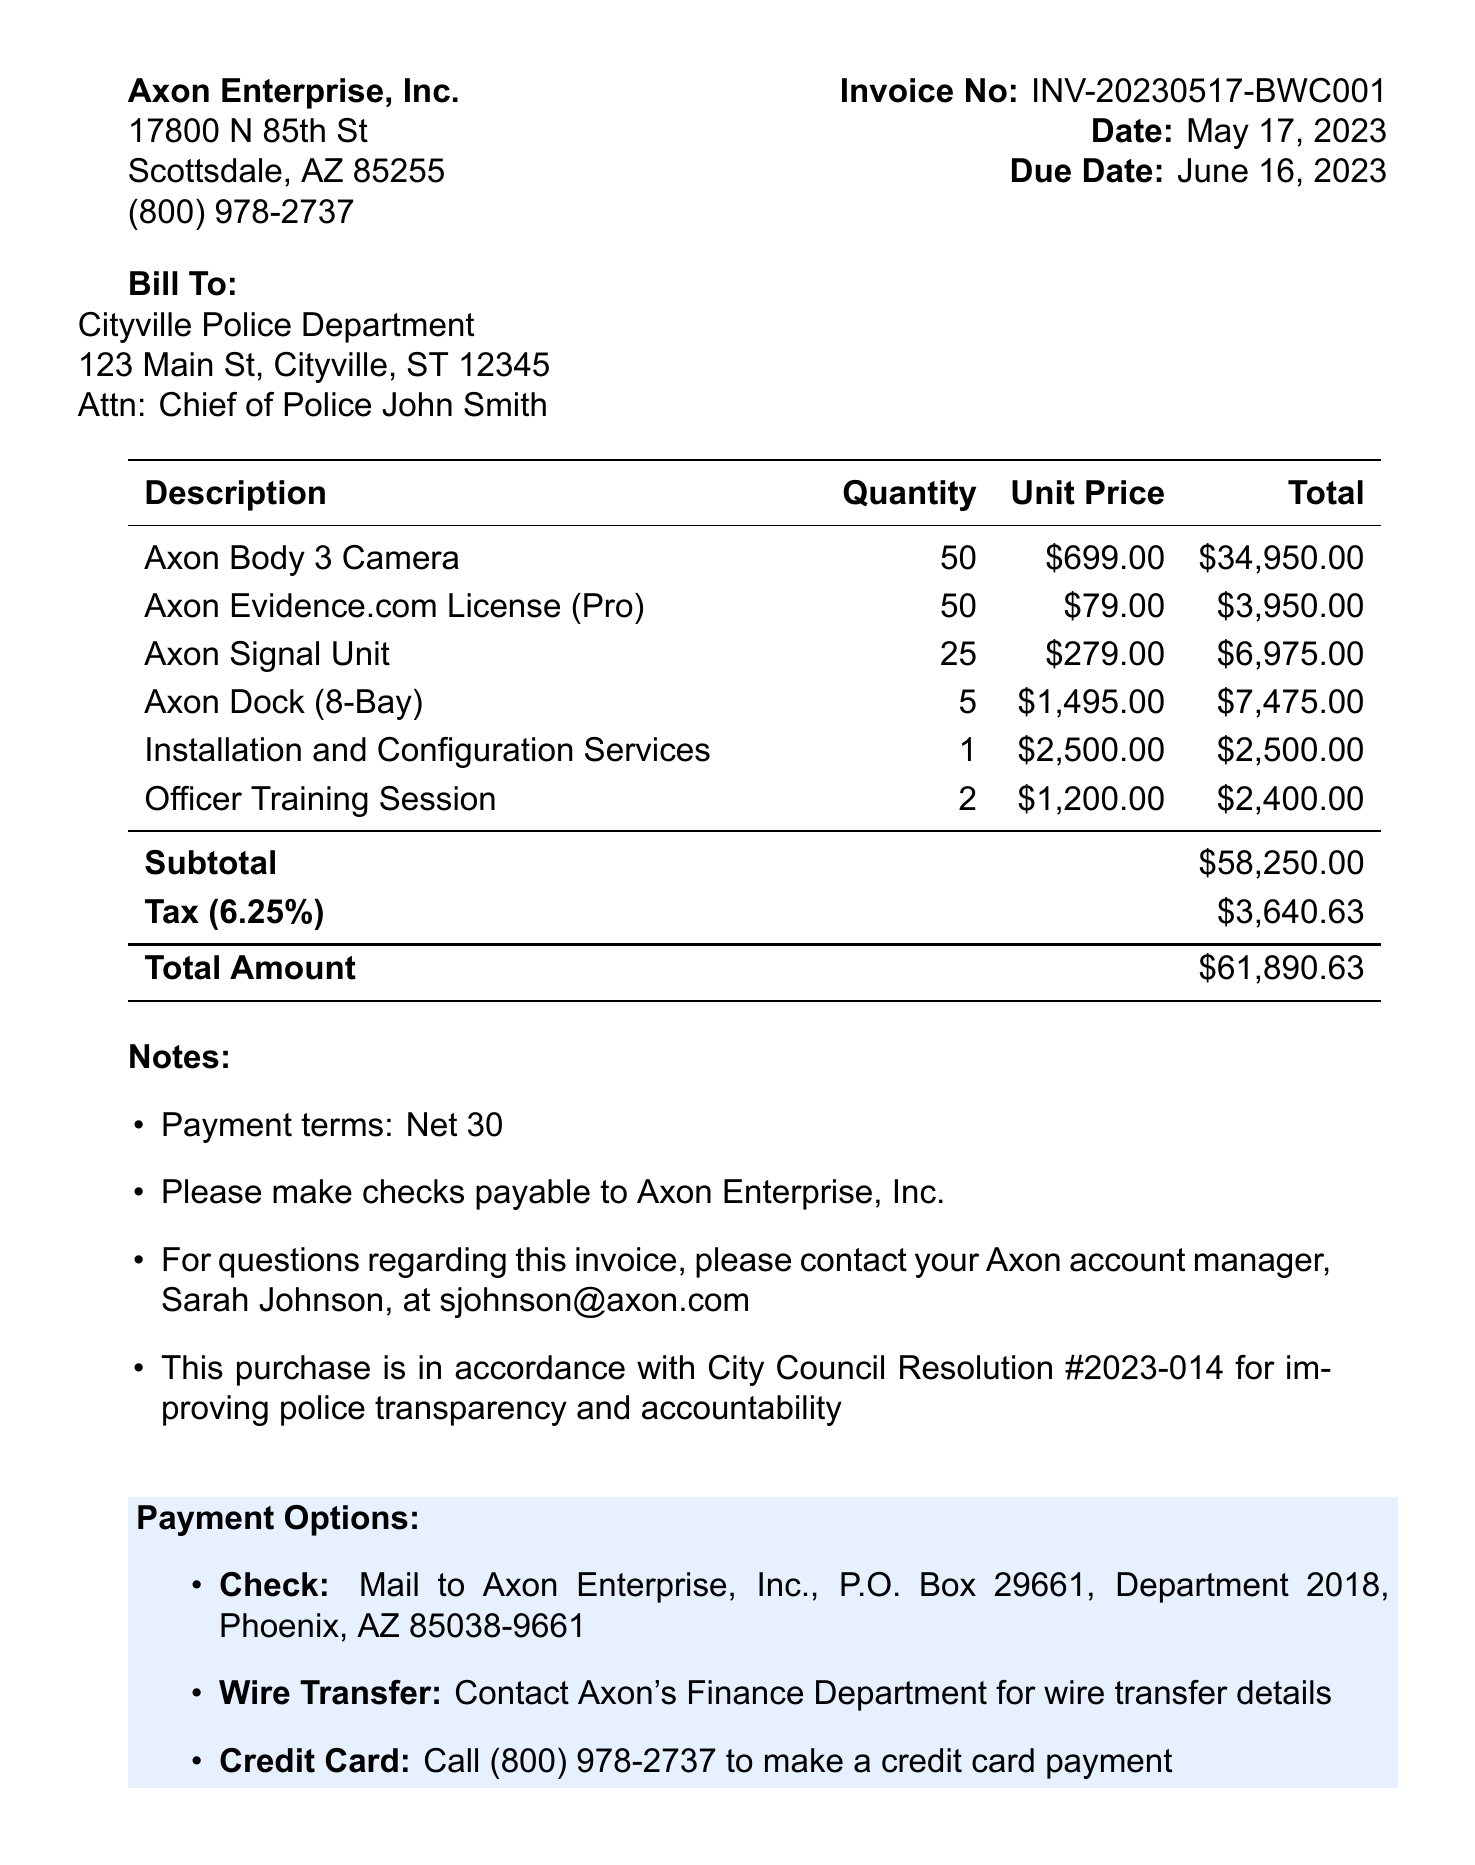What is the invoice number? The invoice number is clearly stated at the top of the document as INV-20230517-BWC001.
Answer: INV-20230517-BWC001 What is the total amount due? The total amount due is calculated at the bottom of the document, which is $61,890.63.
Answer: $61,890.63 Who is the vendor? The vendor's name and address are provided, identified as Axon Enterprise, Inc.
Answer: Axon Enterprise, Inc What is the quantity of Axon Body 3 Cameras purchased? The document lists the quantity of Axon Body 3 Cameras purchased as 50.
Answer: 50 What is the tax rate applied? The tax rate is indicated in the document as 6.25%.
Answer: 6.25% What services are included in the purchase? The purchase includes various items, including installation and configuration services, as well as officer training sessions.
Answer: Installation and Configuration Services, Officer Training Session What payment methods are available? The document provides options for payment methods, which include Check, Wire Transfer, and Credit Card.
Answer: Check, Wire Transfer, Credit Card What is the due date for payment? The due date for payment is specified in the document as June 16, 2023.
Answer: June 16, 2023 Who should inquiries regarding the invoice be directed to? The document states that inquiries about the invoice should be directed to the Axon account manager, Sarah Johnson.
Answer: Sarah Johnson 